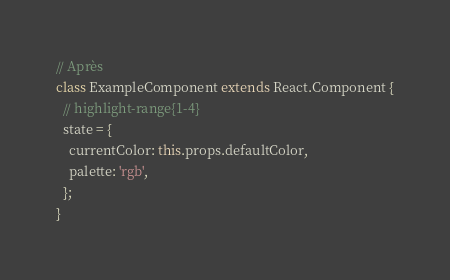<code> <loc_0><loc_0><loc_500><loc_500><_JavaScript_>// Après
class ExampleComponent extends React.Component {
  // highlight-range{1-4}
  state = {
    currentColor: this.props.defaultColor,
    palette: 'rgb',
  };
}
</code> 